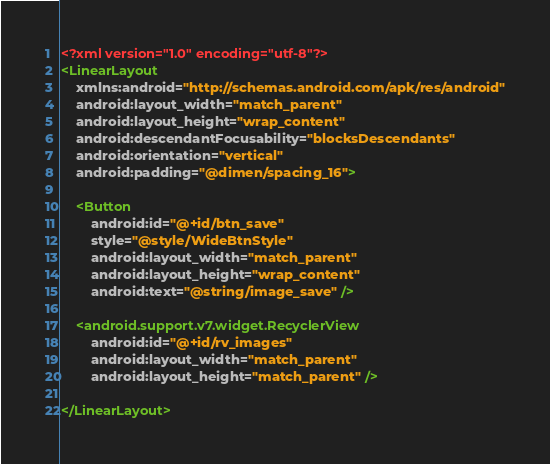Convert code to text. <code><loc_0><loc_0><loc_500><loc_500><_XML_><?xml version="1.0" encoding="utf-8"?>
<LinearLayout
    xmlns:android="http://schemas.android.com/apk/res/android"
    android:layout_width="match_parent"
    android:layout_height="wrap_content"
    android:descendantFocusability="blocksDescendants"
    android:orientation="vertical"
    android:padding="@dimen/spacing_16">

    <Button
        android:id="@+id/btn_save"
        style="@style/WideBtnStyle"
        android:layout_width="match_parent"
        android:layout_height="wrap_content"
        android:text="@string/image_save" />

    <android.support.v7.widget.RecyclerView
        android:id="@+id/rv_images"
        android:layout_width="match_parent"
        android:layout_height="match_parent" />

</LinearLayout></code> 